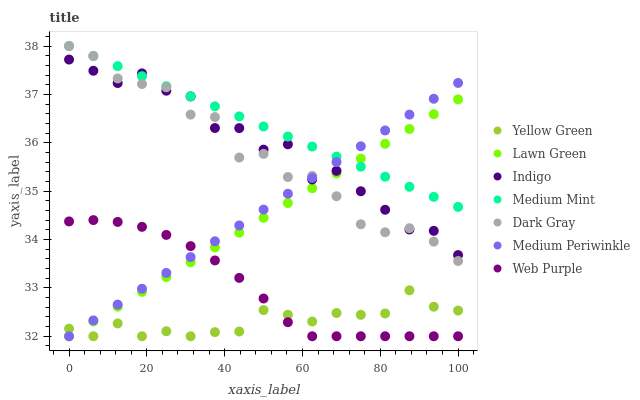Does Yellow Green have the minimum area under the curve?
Answer yes or no. Yes. Does Medium Mint have the maximum area under the curve?
Answer yes or no. Yes. Does Lawn Green have the minimum area under the curve?
Answer yes or no. No. Does Lawn Green have the maximum area under the curve?
Answer yes or no. No. Is Medium Mint the smoothest?
Answer yes or no. Yes. Is Indigo the roughest?
Answer yes or no. Yes. Is Lawn Green the smoothest?
Answer yes or no. No. Is Lawn Green the roughest?
Answer yes or no. No. Does Lawn Green have the lowest value?
Answer yes or no. Yes. Does Indigo have the lowest value?
Answer yes or no. No. Does Dark Gray have the highest value?
Answer yes or no. Yes. Does Lawn Green have the highest value?
Answer yes or no. No. Is Yellow Green less than Dark Gray?
Answer yes or no. Yes. Is Medium Mint greater than Web Purple?
Answer yes or no. Yes. Does Indigo intersect Medium Mint?
Answer yes or no. Yes. Is Indigo less than Medium Mint?
Answer yes or no. No. Is Indigo greater than Medium Mint?
Answer yes or no. No. Does Yellow Green intersect Dark Gray?
Answer yes or no. No. 